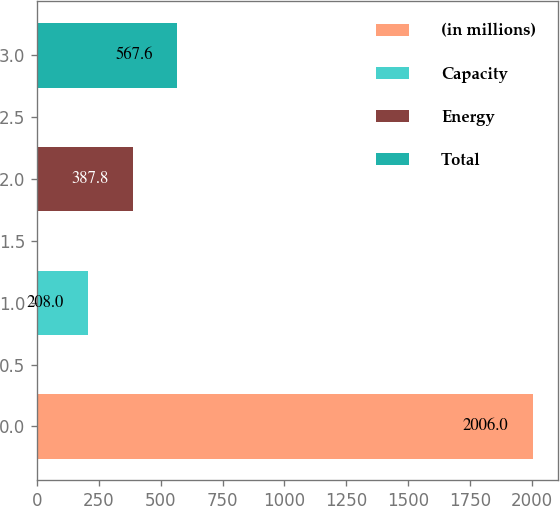Convert chart to OTSL. <chart><loc_0><loc_0><loc_500><loc_500><bar_chart><fcel>(in millions)<fcel>Capacity<fcel>Energy<fcel>Total<nl><fcel>2006<fcel>208<fcel>387.8<fcel>567.6<nl></chart> 